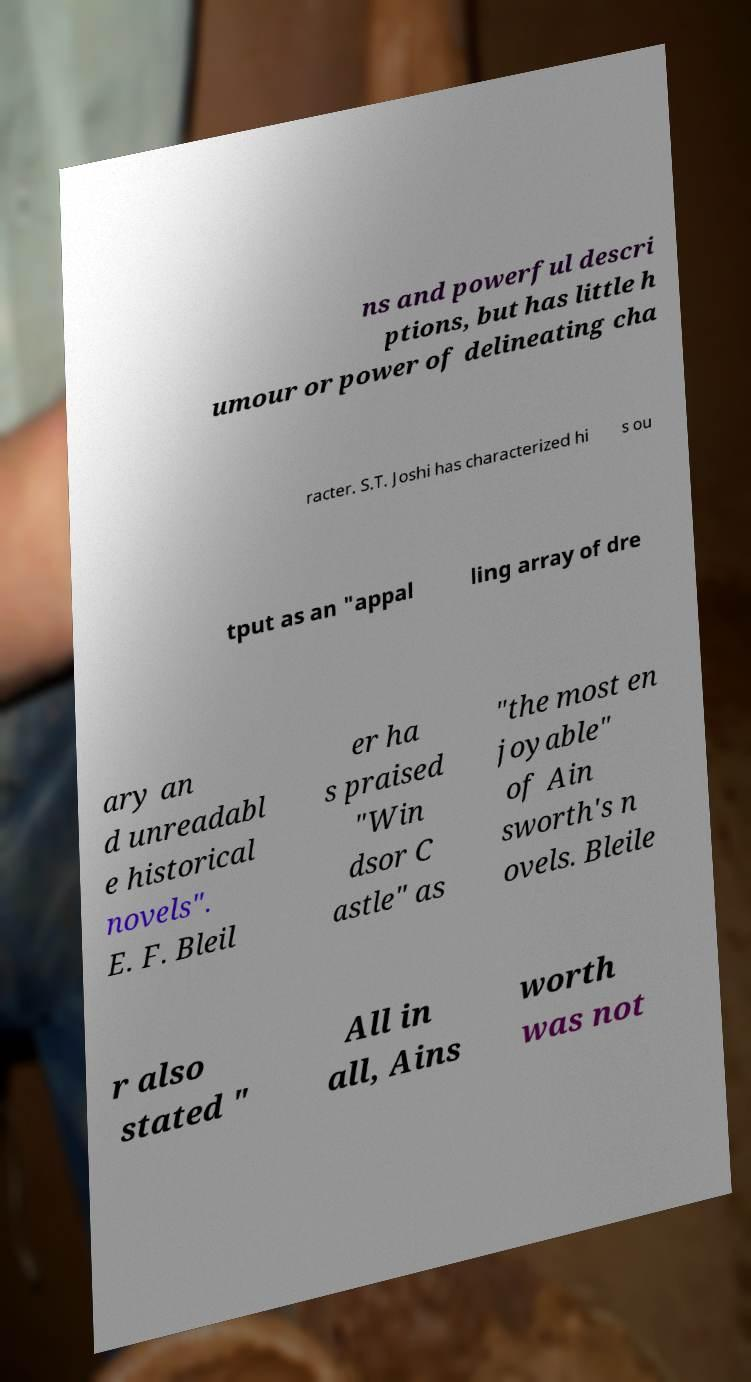Could you assist in decoding the text presented in this image and type it out clearly? ns and powerful descri ptions, but has little h umour or power of delineating cha racter. S.T. Joshi has characterized hi s ou tput as an "appal ling array of dre ary an d unreadabl e historical novels". E. F. Bleil er ha s praised "Win dsor C astle" as "the most en joyable" of Ain sworth's n ovels. Bleile r also stated " All in all, Ains worth was not 